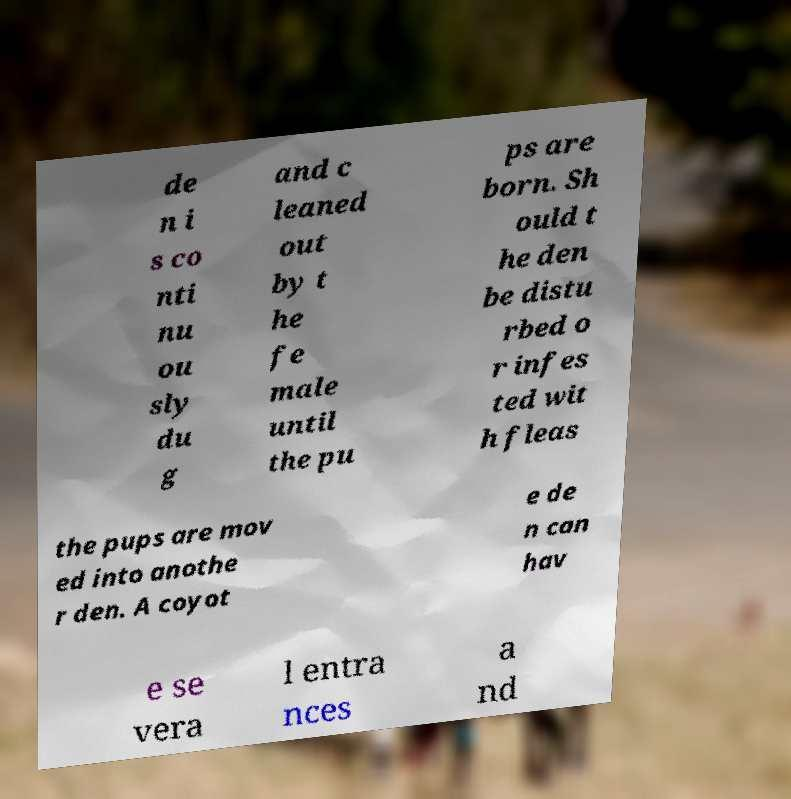I need the written content from this picture converted into text. Can you do that? de n i s co nti nu ou sly du g and c leaned out by t he fe male until the pu ps are born. Sh ould t he den be distu rbed o r infes ted wit h fleas the pups are mov ed into anothe r den. A coyot e de n can hav e se vera l entra nces a nd 